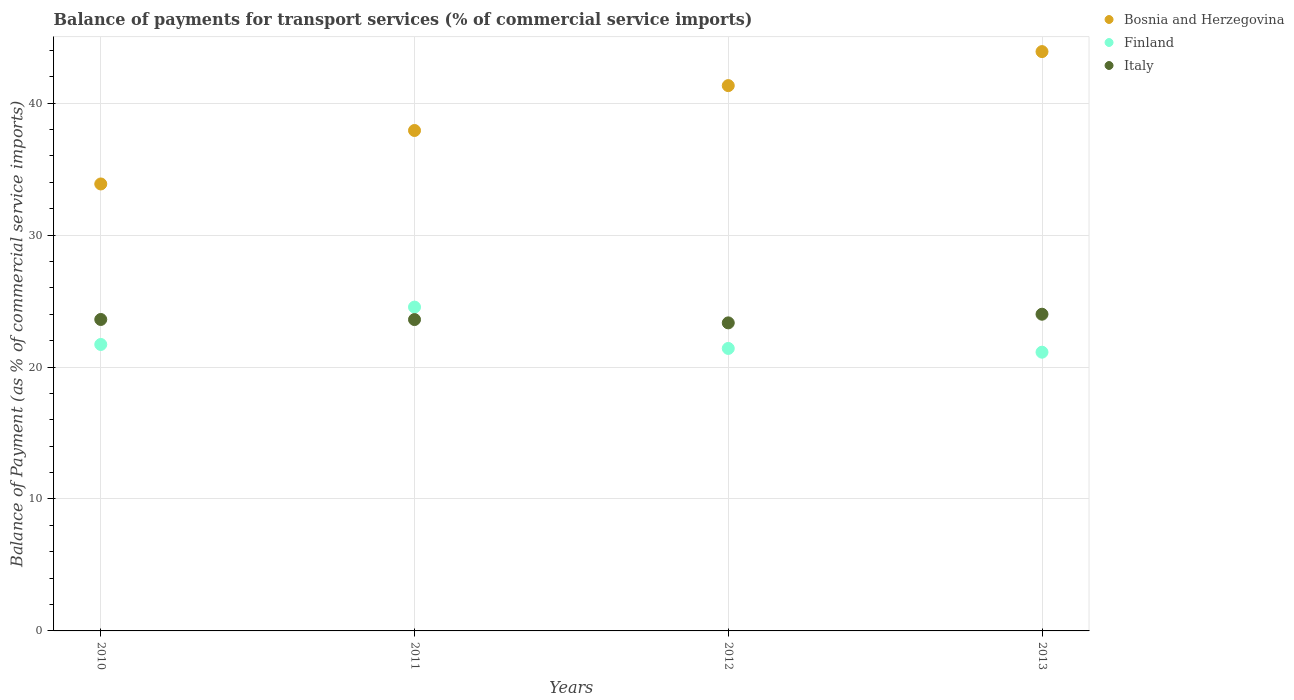What is the balance of payments for transport services in Finland in 2013?
Offer a terse response. 21.13. Across all years, what is the maximum balance of payments for transport services in Italy?
Offer a very short reply. 24. Across all years, what is the minimum balance of payments for transport services in Italy?
Keep it short and to the point. 23.35. In which year was the balance of payments for transport services in Finland maximum?
Provide a short and direct response. 2011. What is the total balance of payments for transport services in Italy in the graph?
Your response must be concise. 94.56. What is the difference between the balance of payments for transport services in Bosnia and Herzegovina in 2010 and that in 2013?
Give a very brief answer. -10.03. What is the difference between the balance of payments for transport services in Italy in 2013 and the balance of payments for transport services in Finland in 2010?
Give a very brief answer. 2.29. What is the average balance of payments for transport services in Finland per year?
Provide a succinct answer. 22.2. In the year 2010, what is the difference between the balance of payments for transport services in Italy and balance of payments for transport services in Bosnia and Herzegovina?
Offer a terse response. -10.27. What is the ratio of the balance of payments for transport services in Finland in 2011 to that in 2012?
Ensure brevity in your answer.  1.15. What is the difference between the highest and the second highest balance of payments for transport services in Finland?
Provide a short and direct response. 2.83. What is the difference between the highest and the lowest balance of payments for transport services in Bosnia and Herzegovina?
Offer a very short reply. 10.03. Does the balance of payments for transport services in Finland monotonically increase over the years?
Your response must be concise. No. Is the balance of payments for transport services in Finland strictly greater than the balance of payments for transport services in Italy over the years?
Keep it short and to the point. No. Is the balance of payments for transport services in Bosnia and Herzegovina strictly less than the balance of payments for transport services in Italy over the years?
Offer a terse response. No. What is the difference between two consecutive major ticks on the Y-axis?
Ensure brevity in your answer.  10. Does the graph contain any zero values?
Provide a short and direct response. No. Does the graph contain grids?
Offer a terse response. Yes. How many legend labels are there?
Provide a succinct answer. 3. How are the legend labels stacked?
Your answer should be compact. Vertical. What is the title of the graph?
Offer a very short reply. Balance of payments for transport services (% of commercial service imports). Does "Burundi" appear as one of the legend labels in the graph?
Provide a short and direct response. No. What is the label or title of the Y-axis?
Your answer should be very brief. Balance of Payment (as % of commercial service imports). What is the Balance of Payment (as % of commercial service imports) in Bosnia and Herzegovina in 2010?
Your answer should be compact. 33.88. What is the Balance of Payment (as % of commercial service imports) of Finland in 2010?
Give a very brief answer. 21.71. What is the Balance of Payment (as % of commercial service imports) of Italy in 2010?
Offer a terse response. 23.61. What is the Balance of Payment (as % of commercial service imports) in Bosnia and Herzegovina in 2011?
Make the answer very short. 37.93. What is the Balance of Payment (as % of commercial service imports) in Finland in 2011?
Your answer should be very brief. 24.54. What is the Balance of Payment (as % of commercial service imports) of Italy in 2011?
Offer a very short reply. 23.6. What is the Balance of Payment (as % of commercial service imports) of Bosnia and Herzegovina in 2012?
Your answer should be very brief. 41.33. What is the Balance of Payment (as % of commercial service imports) of Finland in 2012?
Keep it short and to the point. 21.41. What is the Balance of Payment (as % of commercial service imports) in Italy in 2012?
Your answer should be very brief. 23.35. What is the Balance of Payment (as % of commercial service imports) of Bosnia and Herzegovina in 2013?
Keep it short and to the point. 43.91. What is the Balance of Payment (as % of commercial service imports) in Finland in 2013?
Offer a terse response. 21.13. What is the Balance of Payment (as % of commercial service imports) in Italy in 2013?
Provide a short and direct response. 24. Across all years, what is the maximum Balance of Payment (as % of commercial service imports) of Bosnia and Herzegovina?
Ensure brevity in your answer.  43.91. Across all years, what is the maximum Balance of Payment (as % of commercial service imports) in Finland?
Your answer should be very brief. 24.54. Across all years, what is the maximum Balance of Payment (as % of commercial service imports) in Italy?
Offer a terse response. 24. Across all years, what is the minimum Balance of Payment (as % of commercial service imports) of Bosnia and Herzegovina?
Your response must be concise. 33.88. Across all years, what is the minimum Balance of Payment (as % of commercial service imports) in Finland?
Keep it short and to the point. 21.13. Across all years, what is the minimum Balance of Payment (as % of commercial service imports) in Italy?
Ensure brevity in your answer.  23.35. What is the total Balance of Payment (as % of commercial service imports) of Bosnia and Herzegovina in the graph?
Your answer should be compact. 157.04. What is the total Balance of Payment (as % of commercial service imports) in Finland in the graph?
Provide a short and direct response. 88.79. What is the total Balance of Payment (as % of commercial service imports) in Italy in the graph?
Provide a short and direct response. 94.56. What is the difference between the Balance of Payment (as % of commercial service imports) of Bosnia and Herzegovina in 2010 and that in 2011?
Your answer should be very brief. -4.05. What is the difference between the Balance of Payment (as % of commercial service imports) in Finland in 2010 and that in 2011?
Make the answer very short. -2.83. What is the difference between the Balance of Payment (as % of commercial service imports) in Italy in 2010 and that in 2011?
Make the answer very short. 0.01. What is the difference between the Balance of Payment (as % of commercial service imports) in Bosnia and Herzegovina in 2010 and that in 2012?
Provide a succinct answer. -7.45. What is the difference between the Balance of Payment (as % of commercial service imports) of Finland in 2010 and that in 2012?
Offer a terse response. 0.3. What is the difference between the Balance of Payment (as % of commercial service imports) of Italy in 2010 and that in 2012?
Offer a very short reply. 0.26. What is the difference between the Balance of Payment (as % of commercial service imports) in Bosnia and Herzegovina in 2010 and that in 2013?
Provide a succinct answer. -10.03. What is the difference between the Balance of Payment (as % of commercial service imports) of Finland in 2010 and that in 2013?
Give a very brief answer. 0.58. What is the difference between the Balance of Payment (as % of commercial service imports) of Italy in 2010 and that in 2013?
Ensure brevity in your answer.  -0.4. What is the difference between the Balance of Payment (as % of commercial service imports) in Bosnia and Herzegovina in 2011 and that in 2012?
Your answer should be compact. -3.4. What is the difference between the Balance of Payment (as % of commercial service imports) in Finland in 2011 and that in 2012?
Offer a terse response. 3.13. What is the difference between the Balance of Payment (as % of commercial service imports) in Italy in 2011 and that in 2012?
Provide a short and direct response. 0.25. What is the difference between the Balance of Payment (as % of commercial service imports) of Bosnia and Herzegovina in 2011 and that in 2013?
Give a very brief answer. -5.98. What is the difference between the Balance of Payment (as % of commercial service imports) of Finland in 2011 and that in 2013?
Give a very brief answer. 3.42. What is the difference between the Balance of Payment (as % of commercial service imports) of Italy in 2011 and that in 2013?
Offer a very short reply. -0.41. What is the difference between the Balance of Payment (as % of commercial service imports) in Bosnia and Herzegovina in 2012 and that in 2013?
Keep it short and to the point. -2.58. What is the difference between the Balance of Payment (as % of commercial service imports) of Finland in 2012 and that in 2013?
Ensure brevity in your answer.  0.28. What is the difference between the Balance of Payment (as % of commercial service imports) of Italy in 2012 and that in 2013?
Ensure brevity in your answer.  -0.66. What is the difference between the Balance of Payment (as % of commercial service imports) of Bosnia and Herzegovina in 2010 and the Balance of Payment (as % of commercial service imports) of Finland in 2011?
Ensure brevity in your answer.  9.33. What is the difference between the Balance of Payment (as % of commercial service imports) in Bosnia and Herzegovina in 2010 and the Balance of Payment (as % of commercial service imports) in Italy in 2011?
Offer a very short reply. 10.28. What is the difference between the Balance of Payment (as % of commercial service imports) of Finland in 2010 and the Balance of Payment (as % of commercial service imports) of Italy in 2011?
Your answer should be compact. -1.89. What is the difference between the Balance of Payment (as % of commercial service imports) of Bosnia and Herzegovina in 2010 and the Balance of Payment (as % of commercial service imports) of Finland in 2012?
Provide a short and direct response. 12.47. What is the difference between the Balance of Payment (as % of commercial service imports) of Bosnia and Herzegovina in 2010 and the Balance of Payment (as % of commercial service imports) of Italy in 2012?
Provide a short and direct response. 10.53. What is the difference between the Balance of Payment (as % of commercial service imports) in Finland in 2010 and the Balance of Payment (as % of commercial service imports) in Italy in 2012?
Offer a terse response. -1.64. What is the difference between the Balance of Payment (as % of commercial service imports) in Bosnia and Herzegovina in 2010 and the Balance of Payment (as % of commercial service imports) in Finland in 2013?
Your answer should be very brief. 12.75. What is the difference between the Balance of Payment (as % of commercial service imports) of Bosnia and Herzegovina in 2010 and the Balance of Payment (as % of commercial service imports) of Italy in 2013?
Make the answer very short. 9.87. What is the difference between the Balance of Payment (as % of commercial service imports) of Finland in 2010 and the Balance of Payment (as % of commercial service imports) of Italy in 2013?
Your answer should be compact. -2.29. What is the difference between the Balance of Payment (as % of commercial service imports) in Bosnia and Herzegovina in 2011 and the Balance of Payment (as % of commercial service imports) in Finland in 2012?
Your answer should be compact. 16.52. What is the difference between the Balance of Payment (as % of commercial service imports) in Bosnia and Herzegovina in 2011 and the Balance of Payment (as % of commercial service imports) in Italy in 2012?
Ensure brevity in your answer.  14.58. What is the difference between the Balance of Payment (as % of commercial service imports) of Finland in 2011 and the Balance of Payment (as % of commercial service imports) of Italy in 2012?
Give a very brief answer. 1.2. What is the difference between the Balance of Payment (as % of commercial service imports) in Bosnia and Herzegovina in 2011 and the Balance of Payment (as % of commercial service imports) in Finland in 2013?
Your answer should be compact. 16.8. What is the difference between the Balance of Payment (as % of commercial service imports) in Bosnia and Herzegovina in 2011 and the Balance of Payment (as % of commercial service imports) in Italy in 2013?
Keep it short and to the point. 13.93. What is the difference between the Balance of Payment (as % of commercial service imports) of Finland in 2011 and the Balance of Payment (as % of commercial service imports) of Italy in 2013?
Provide a short and direct response. 0.54. What is the difference between the Balance of Payment (as % of commercial service imports) of Bosnia and Herzegovina in 2012 and the Balance of Payment (as % of commercial service imports) of Finland in 2013?
Make the answer very short. 20.2. What is the difference between the Balance of Payment (as % of commercial service imports) in Bosnia and Herzegovina in 2012 and the Balance of Payment (as % of commercial service imports) in Italy in 2013?
Offer a very short reply. 17.33. What is the difference between the Balance of Payment (as % of commercial service imports) in Finland in 2012 and the Balance of Payment (as % of commercial service imports) in Italy in 2013?
Your response must be concise. -2.59. What is the average Balance of Payment (as % of commercial service imports) of Bosnia and Herzegovina per year?
Your answer should be compact. 39.26. What is the average Balance of Payment (as % of commercial service imports) of Finland per year?
Keep it short and to the point. 22.2. What is the average Balance of Payment (as % of commercial service imports) of Italy per year?
Your answer should be compact. 23.64. In the year 2010, what is the difference between the Balance of Payment (as % of commercial service imports) of Bosnia and Herzegovina and Balance of Payment (as % of commercial service imports) of Finland?
Your response must be concise. 12.17. In the year 2010, what is the difference between the Balance of Payment (as % of commercial service imports) in Bosnia and Herzegovina and Balance of Payment (as % of commercial service imports) in Italy?
Give a very brief answer. 10.27. In the year 2010, what is the difference between the Balance of Payment (as % of commercial service imports) of Finland and Balance of Payment (as % of commercial service imports) of Italy?
Provide a short and direct response. -1.89. In the year 2011, what is the difference between the Balance of Payment (as % of commercial service imports) of Bosnia and Herzegovina and Balance of Payment (as % of commercial service imports) of Finland?
Offer a very short reply. 13.39. In the year 2011, what is the difference between the Balance of Payment (as % of commercial service imports) in Bosnia and Herzegovina and Balance of Payment (as % of commercial service imports) in Italy?
Offer a terse response. 14.33. In the year 2011, what is the difference between the Balance of Payment (as % of commercial service imports) of Finland and Balance of Payment (as % of commercial service imports) of Italy?
Give a very brief answer. 0.94. In the year 2012, what is the difference between the Balance of Payment (as % of commercial service imports) in Bosnia and Herzegovina and Balance of Payment (as % of commercial service imports) in Finland?
Your answer should be very brief. 19.92. In the year 2012, what is the difference between the Balance of Payment (as % of commercial service imports) in Bosnia and Herzegovina and Balance of Payment (as % of commercial service imports) in Italy?
Offer a terse response. 17.98. In the year 2012, what is the difference between the Balance of Payment (as % of commercial service imports) in Finland and Balance of Payment (as % of commercial service imports) in Italy?
Provide a short and direct response. -1.94. In the year 2013, what is the difference between the Balance of Payment (as % of commercial service imports) in Bosnia and Herzegovina and Balance of Payment (as % of commercial service imports) in Finland?
Ensure brevity in your answer.  22.78. In the year 2013, what is the difference between the Balance of Payment (as % of commercial service imports) of Bosnia and Herzegovina and Balance of Payment (as % of commercial service imports) of Italy?
Offer a terse response. 19.9. In the year 2013, what is the difference between the Balance of Payment (as % of commercial service imports) in Finland and Balance of Payment (as % of commercial service imports) in Italy?
Give a very brief answer. -2.88. What is the ratio of the Balance of Payment (as % of commercial service imports) of Bosnia and Herzegovina in 2010 to that in 2011?
Your response must be concise. 0.89. What is the ratio of the Balance of Payment (as % of commercial service imports) in Finland in 2010 to that in 2011?
Your answer should be compact. 0.88. What is the ratio of the Balance of Payment (as % of commercial service imports) in Italy in 2010 to that in 2011?
Ensure brevity in your answer.  1. What is the ratio of the Balance of Payment (as % of commercial service imports) in Bosnia and Herzegovina in 2010 to that in 2012?
Provide a succinct answer. 0.82. What is the ratio of the Balance of Payment (as % of commercial service imports) in Italy in 2010 to that in 2012?
Your response must be concise. 1.01. What is the ratio of the Balance of Payment (as % of commercial service imports) in Bosnia and Herzegovina in 2010 to that in 2013?
Your answer should be very brief. 0.77. What is the ratio of the Balance of Payment (as % of commercial service imports) of Finland in 2010 to that in 2013?
Your answer should be compact. 1.03. What is the ratio of the Balance of Payment (as % of commercial service imports) in Italy in 2010 to that in 2013?
Your answer should be very brief. 0.98. What is the ratio of the Balance of Payment (as % of commercial service imports) in Bosnia and Herzegovina in 2011 to that in 2012?
Ensure brevity in your answer.  0.92. What is the ratio of the Balance of Payment (as % of commercial service imports) in Finland in 2011 to that in 2012?
Make the answer very short. 1.15. What is the ratio of the Balance of Payment (as % of commercial service imports) in Italy in 2011 to that in 2012?
Your answer should be very brief. 1.01. What is the ratio of the Balance of Payment (as % of commercial service imports) in Bosnia and Herzegovina in 2011 to that in 2013?
Ensure brevity in your answer.  0.86. What is the ratio of the Balance of Payment (as % of commercial service imports) in Finland in 2011 to that in 2013?
Provide a short and direct response. 1.16. What is the ratio of the Balance of Payment (as % of commercial service imports) of Italy in 2011 to that in 2013?
Your answer should be compact. 0.98. What is the ratio of the Balance of Payment (as % of commercial service imports) in Bosnia and Herzegovina in 2012 to that in 2013?
Offer a terse response. 0.94. What is the ratio of the Balance of Payment (as % of commercial service imports) of Finland in 2012 to that in 2013?
Your answer should be very brief. 1.01. What is the ratio of the Balance of Payment (as % of commercial service imports) of Italy in 2012 to that in 2013?
Your answer should be compact. 0.97. What is the difference between the highest and the second highest Balance of Payment (as % of commercial service imports) in Bosnia and Herzegovina?
Your answer should be very brief. 2.58. What is the difference between the highest and the second highest Balance of Payment (as % of commercial service imports) in Finland?
Your response must be concise. 2.83. What is the difference between the highest and the second highest Balance of Payment (as % of commercial service imports) in Italy?
Your response must be concise. 0.4. What is the difference between the highest and the lowest Balance of Payment (as % of commercial service imports) of Bosnia and Herzegovina?
Keep it short and to the point. 10.03. What is the difference between the highest and the lowest Balance of Payment (as % of commercial service imports) in Finland?
Offer a terse response. 3.42. What is the difference between the highest and the lowest Balance of Payment (as % of commercial service imports) of Italy?
Ensure brevity in your answer.  0.66. 